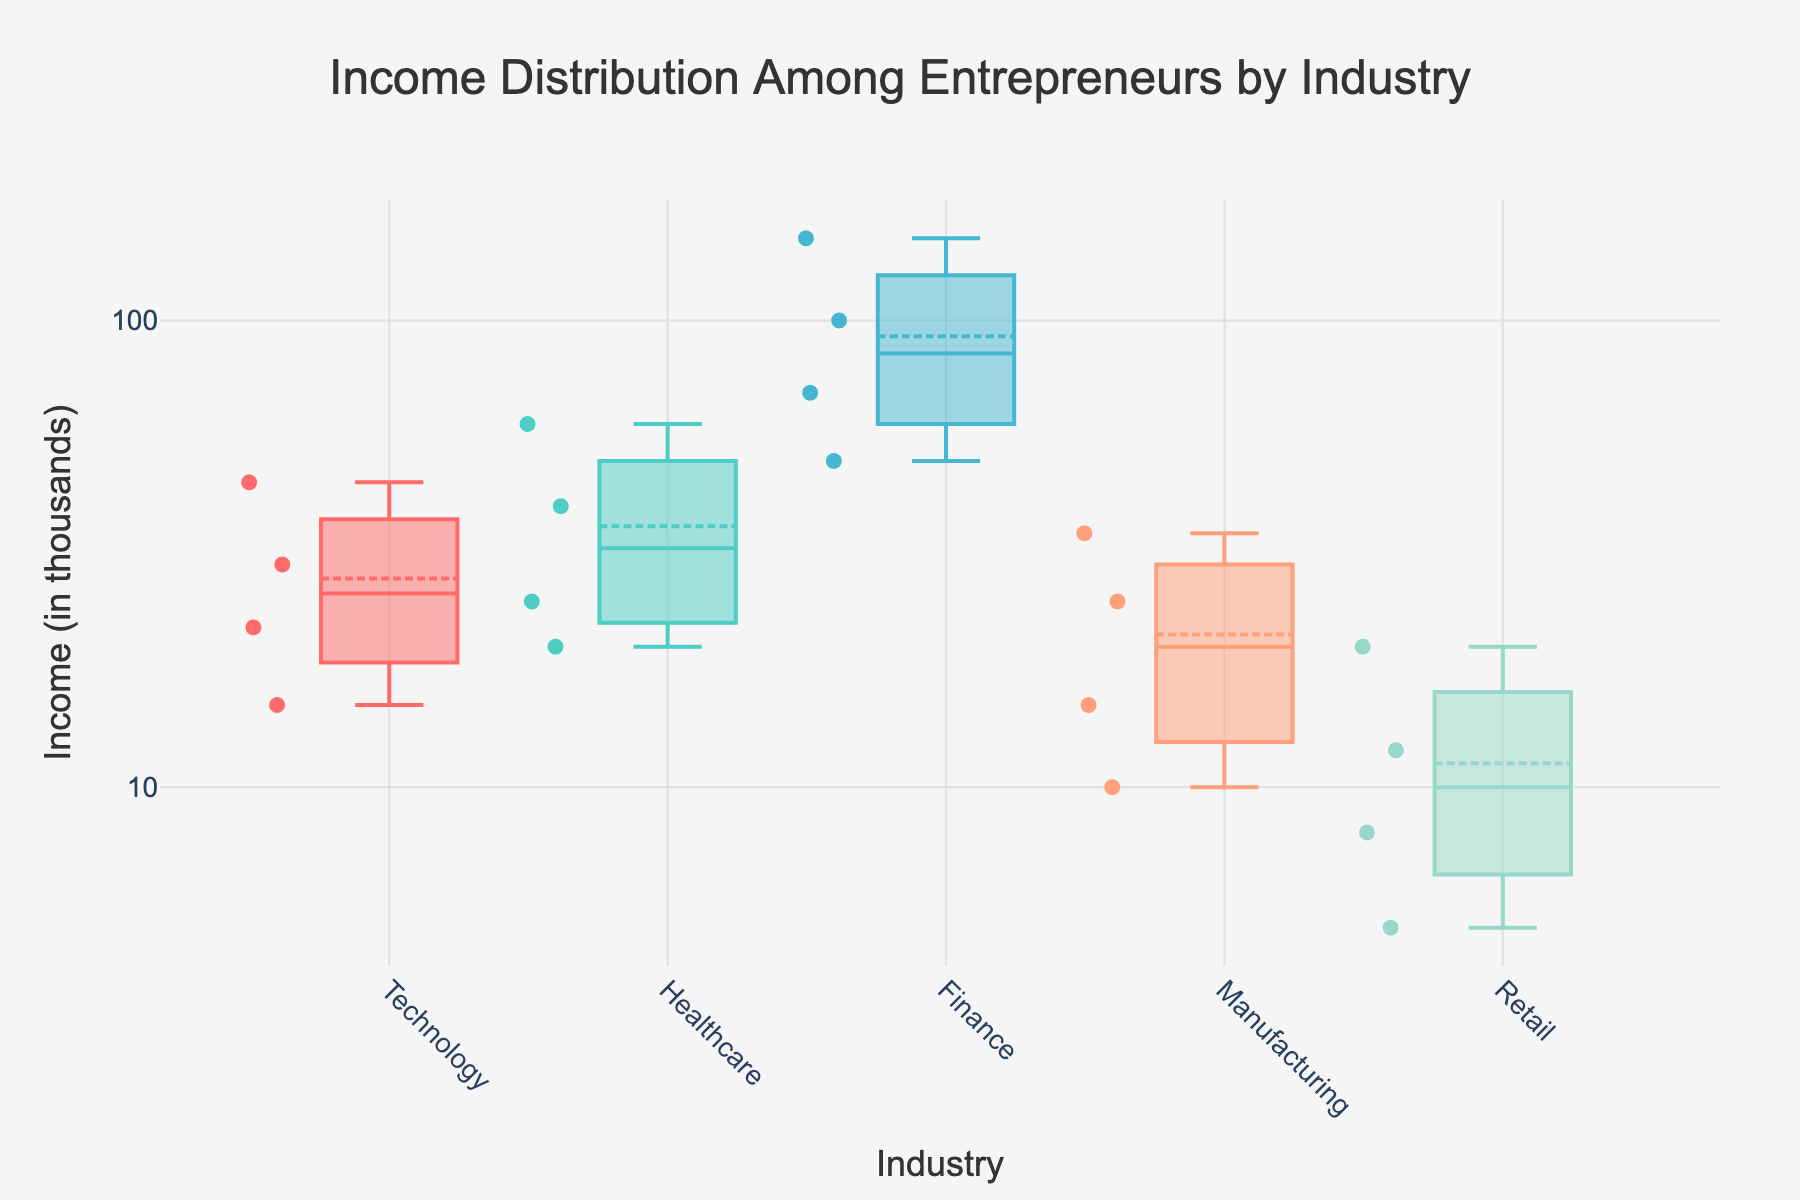What's the title of the plot? The title of the plot is located at the top of the figure, central and bold in appearance. It provides an overview of what the plot depicts.
Answer: Income Distribution Among Entrepreneurs by Industry What is the range of income values represented on the y-axis? The y-axis is presented on a logarithmic scale with tick values ranging from 1 to 1,000. This range is visible based on the axis labels.
Answer: 1 to 1,000 (in thousands) Which industry has the highest income outlier, and what is its value? The Finance industry has the highest income outlier, which is visibly at the top of its box plot. This outlier reaches 150 thousand dollars.
Answer: Finance, 150 (thousands) How does the median income of Technology compare to Healthcare? The median income is represented by the line inside the box. By comparing their positions, the median of Technology appears lower than Healthcare.
Answer: Technology < Healthcare Which industry has the most spread in income distribution? The spread of the data can be assessed by the length of the box plot and whiskers. Finance has the widest spread, covering a larger range from 50 to 150 thousand dollars.
Answer: Finance What is the median income value for the Manufacturing industry? The median income for an industry is indicated by the central line within its box plot. For Manufacturing, this line falls around 15 thousand dollars.
Answer: 15 (thousands) How many income data points are there in the Technology industry? The number of data points is visible as distinct markers within the box plot. By counting these markers, Technology has 4 data points.
Answer: 4 Which industry has the lowest income value, and what is its value? By observing the minimum points of each box plot, Retail has the lowest value which is visible at 5 thousand dollars.
Answer: Retail, 5 (thousands) What is the average income of the Healthcare industry? Determine the exact values in the Healthcare industry (20, 25, 40, 60), sum them (145), and divide by the number of data points (4). The average is 36.25 thousand dollars.
Answer: 36.25 (thousands) How many industries have a median income over 20 thousand dollars? By looking at the median lines in each box plot and comparing them to the 20 thousand mark on the y-axis, Technology, Healthcare, and Finance have median incomes over 20 thousand dollars.
Answer: 3 